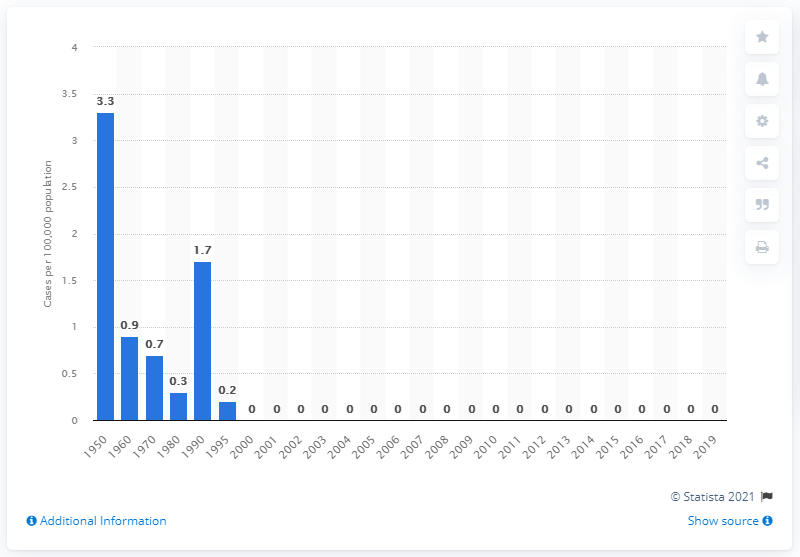List a handful of essential elements in this visual. According to data from 1950, the rate of chancroids per 100,000 people was 3.3. 